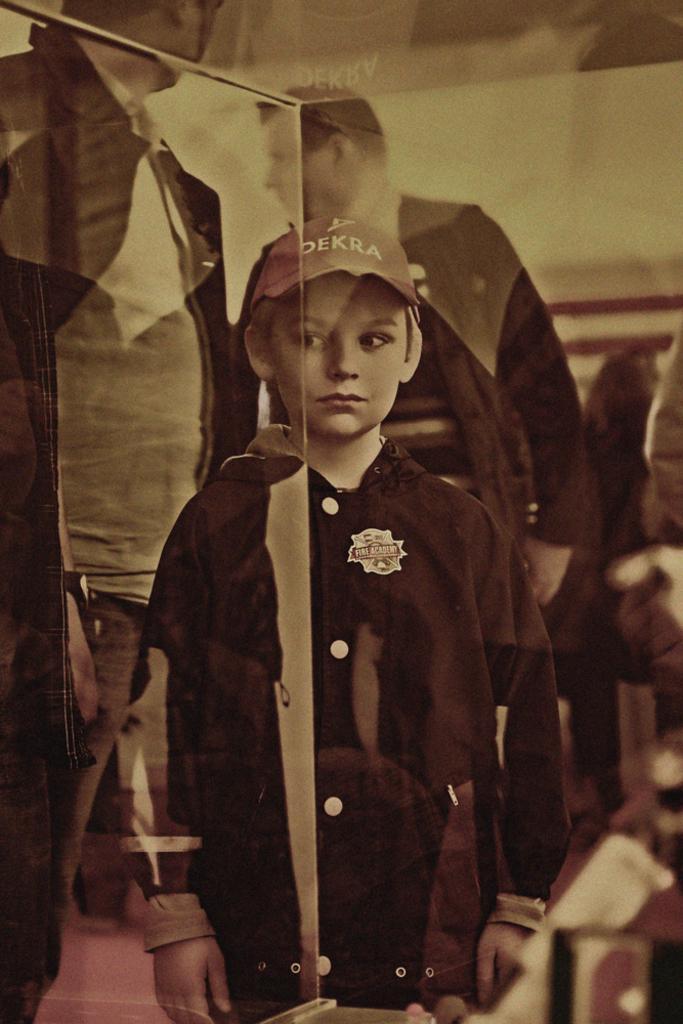Describe this image in one or two sentences. In this image, we can see a boy standing and in the background, there are some other people. 